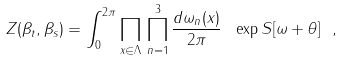<formula> <loc_0><loc_0><loc_500><loc_500>Z ( \beta _ { t } , \beta _ { s } ) = \int _ { 0 } ^ { 2 \pi } \prod _ { x \in \Lambda } \, \prod _ { n = 1 } ^ { 3 } \frac { d \omega _ { n } ( x ) } { 2 \pi } \ \exp { S [ \omega + \theta ] } \ ,</formula> 